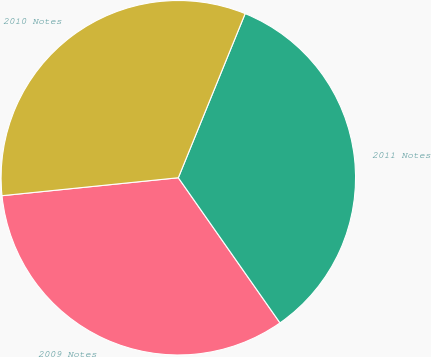Convert chart to OTSL. <chart><loc_0><loc_0><loc_500><loc_500><pie_chart><fcel>2009 Notes<fcel>2011 Notes<fcel>2010 Notes<nl><fcel>33.11%<fcel>34.12%<fcel>32.77%<nl></chart> 